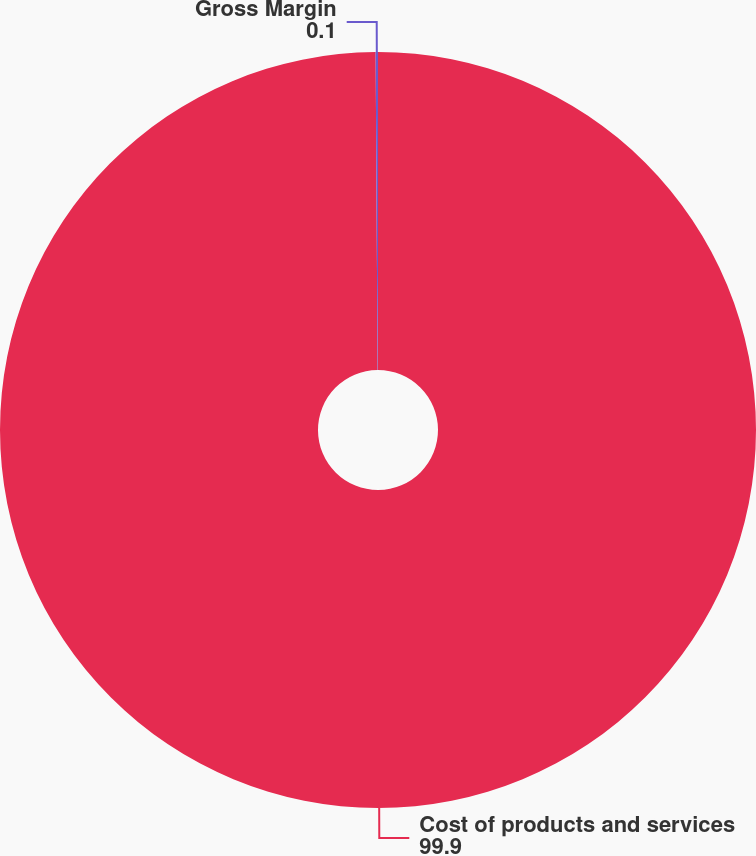Convert chart to OTSL. <chart><loc_0><loc_0><loc_500><loc_500><pie_chart><fcel>Cost of products and services<fcel>Gross Margin<nl><fcel>99.9%<fcel>0.1%<nl></chart> 